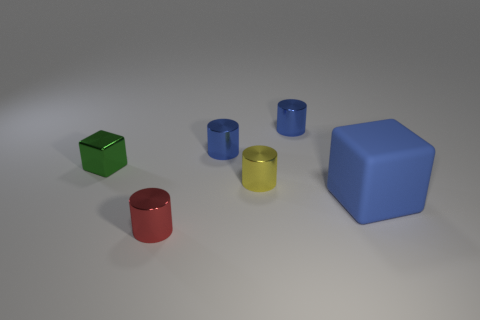Subtract all yellow metal cylinders. How many cylinders are left? 3 Subtract all yellow cylinders. How many cylinders are left? 3 Subtract all cyan balls. How many blue cubes are left? 1 Add 2 blue matte objects. How many objects exist? 8 Subtract all cylinders. How many objects are left? 2 Subtract all red cubes. Subtract all blue spheres. How many cubes are left? 2 Subtract all small shiny things. Subtract all tiny metallic blocks. How many objects are left? 0 Add 5 blue cylinders. How many blue cylinders are left? 7 Add 4 green shiny objects. How many green shiny objects exist? 5 Subtract 0 yellow balls. How many objects are left? 6 